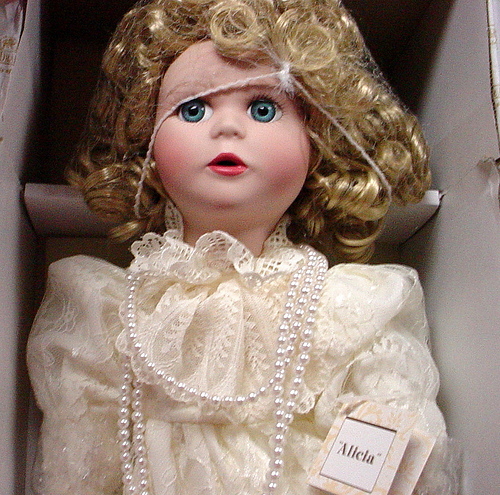<image>
Is there a doll in the box? Yes. The doll is contained within or inside the box, showing a containment relationship. 